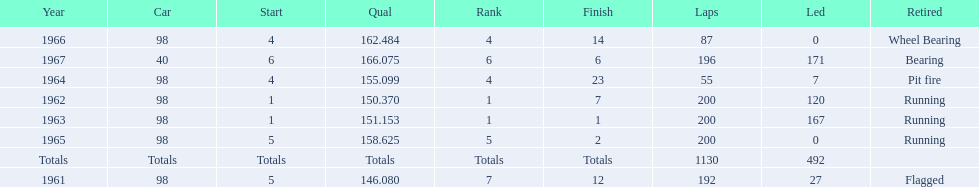Previous to 1965, when did jones have a number 5 start at the indy 500? 1961. 